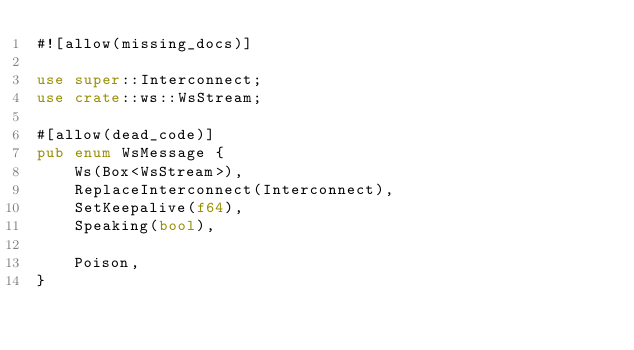Convert code to text. <code><loc_0><loc_0><loc_500><loc_500><_Rust_>#![allow(missing_docs)]

use super::Interconnect;
use crate::ws::WsStream;

#[allow(dead_code)]
pub enum WsMessage {
    Ws(Box<WsStream>),
    ReplaceInterconnect(Interconnect),
    SetKeepalive(f64),
    Speaking(bool),

    Poison,
}
</code> 